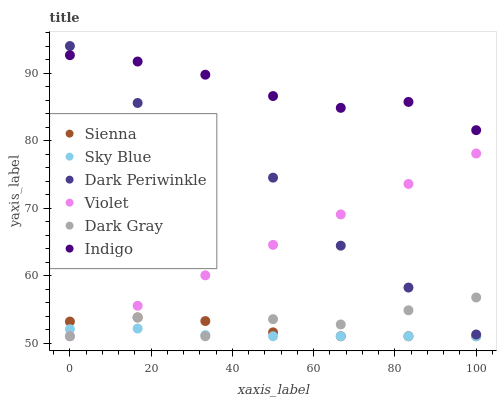Does Sky Blue have the minimum area under the curve?
Answer yes or no. Yes. Does Indigo have the maximum area under the curve?
Answer yes or no. Yes. Does Sienna have the minimum area under the curve?
Answer yes or no. No. Does Sienna have the maximum area under the curve?
Answer yes or no. No. Is Violet the smoothest?
Answer yes or no. Yes. Is Dark Gray the roughest?
Answer yes or no. Yes. Is Indigo the smoothest?
Answer yes or no. No. Is Indigo the roughest?
Answer yes or no. No. Does Dark Gray have the lowest value?
Answer yes or no. Yes. Does Indigo have the lowest value?
Answer yes or no. No. Does Dark Periwinkle have the highest value?
Answer yes or no. Yes. Does Indigo have the highest value?
Answer yes or no. No. Is Sky Blue less than Dark Periwinkle?
Answer yes or no. Yes. Is Indigo greater than Violet?
Answer yes or no. Yes. Does Sky Blue intersect Sienna?
Answer yes or no. Yes. Is Sky Blue less than Sienna?
Answer yes or no. No. Is Sky Blue greater than Sienna?
Answer yes or no. No. Does Sky Blue intersect Dark Periwinkle?
Answer yes or no. No. 